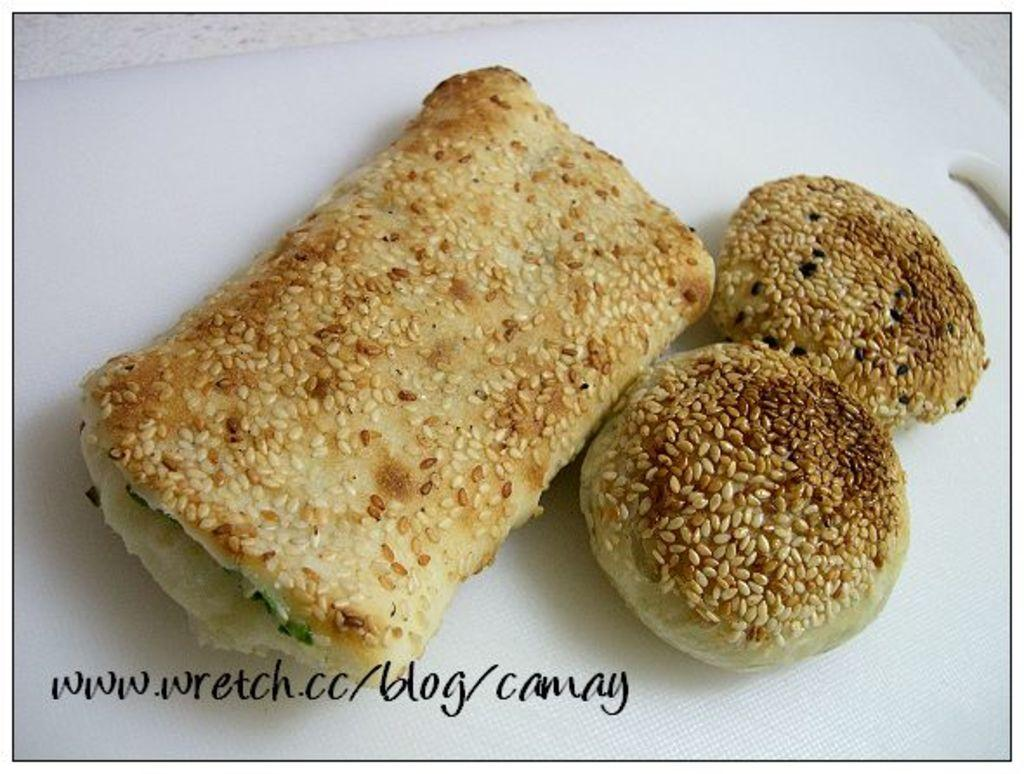What type of food can be seen in the image? There is a food with sesame seeds on a white surface in the image. Can you describe any specific details about the food? Unfortunately, the image does not provide enough detail to describe the food further. Is there any text or marking visible in the image? Yes, there is a watermark at the bottom of the image. What type of crack can be seen on the train tracks in the image? There is no train or crack present in the image; it features a food item with sesame seeds on a white surface and a watermark at the bottom. How is the coal being transported in the image? There is no coal or transportation depicted in the image. 